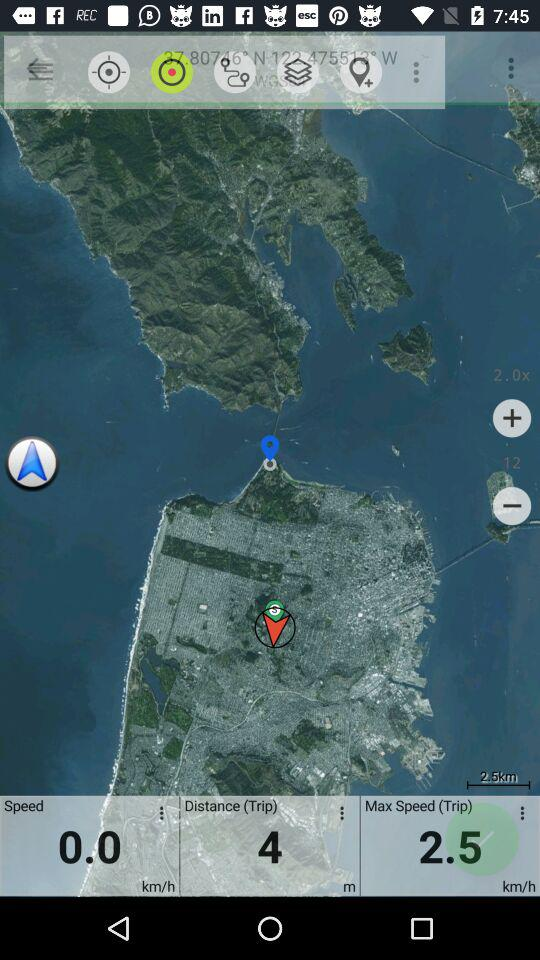What's the shown distance? The distance is 4 m. 